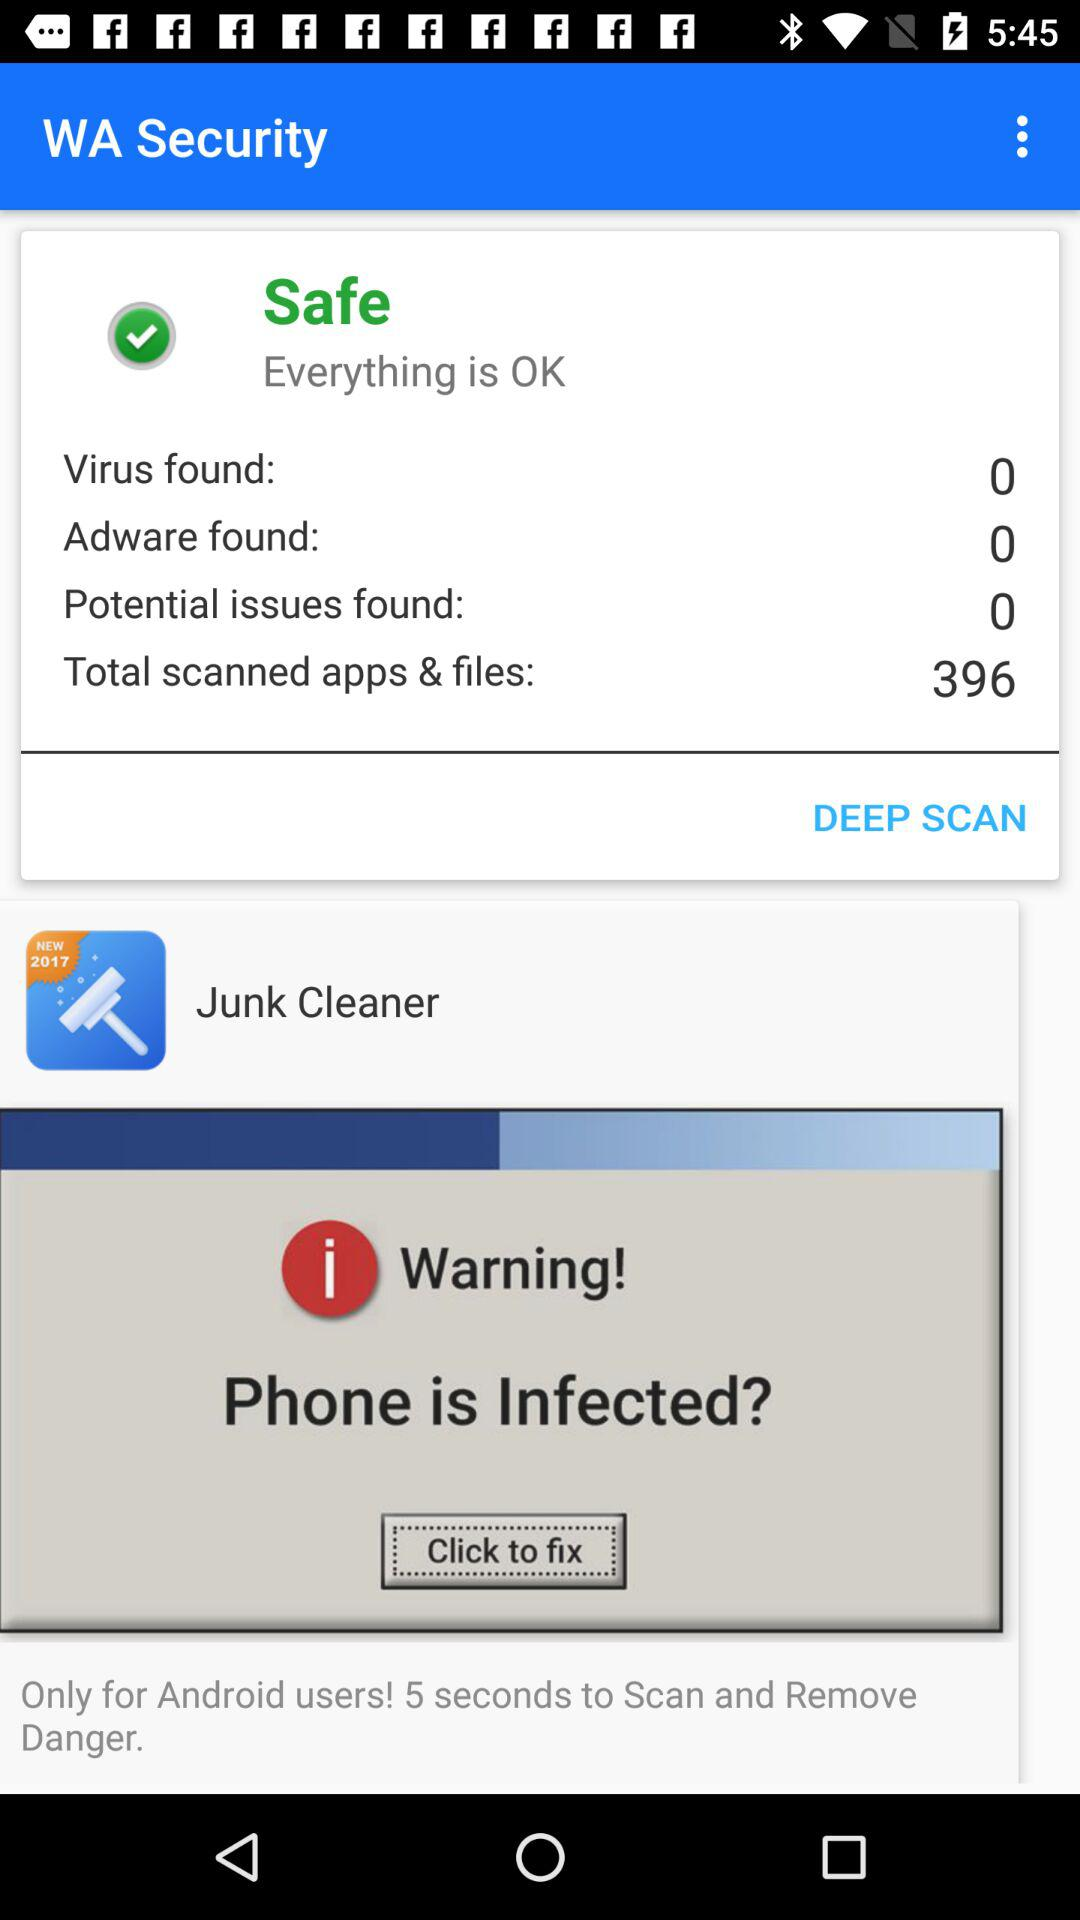How many more potential issues than adware were found?
Answer the question using a single word or phrase. 0 